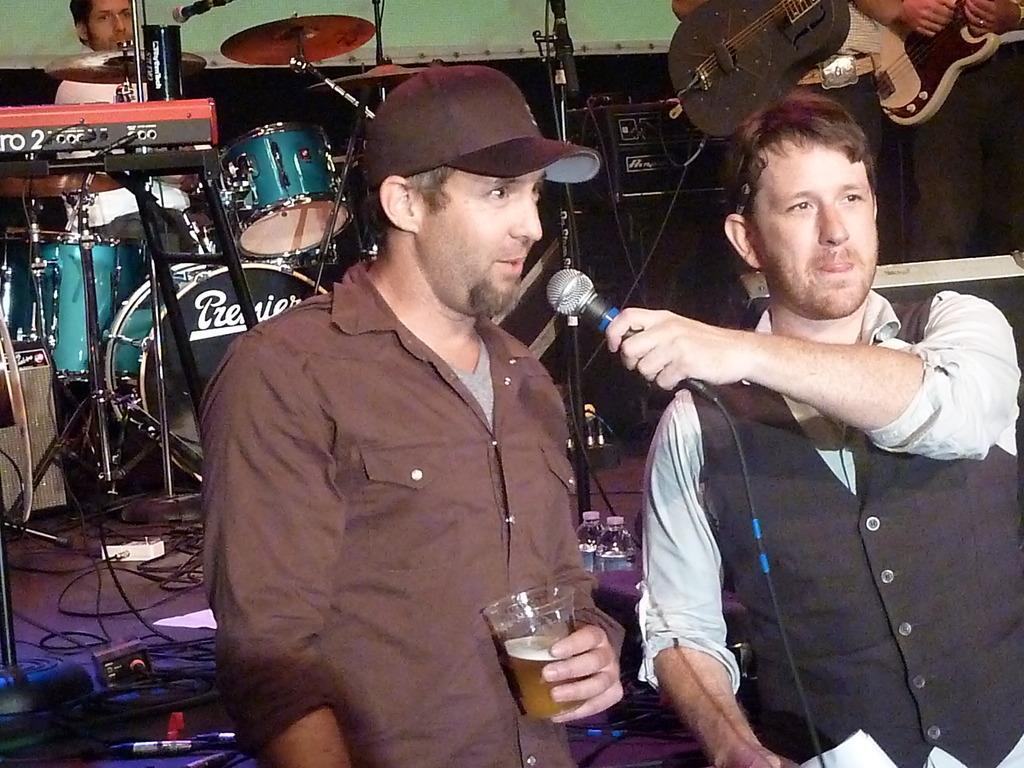Please provide a concise description of this image. In this image we can see group of people in the right side of the image a man holding a microphone in his hand. In the middle of the image a man holding a glass and we can see some musical instruments here. 